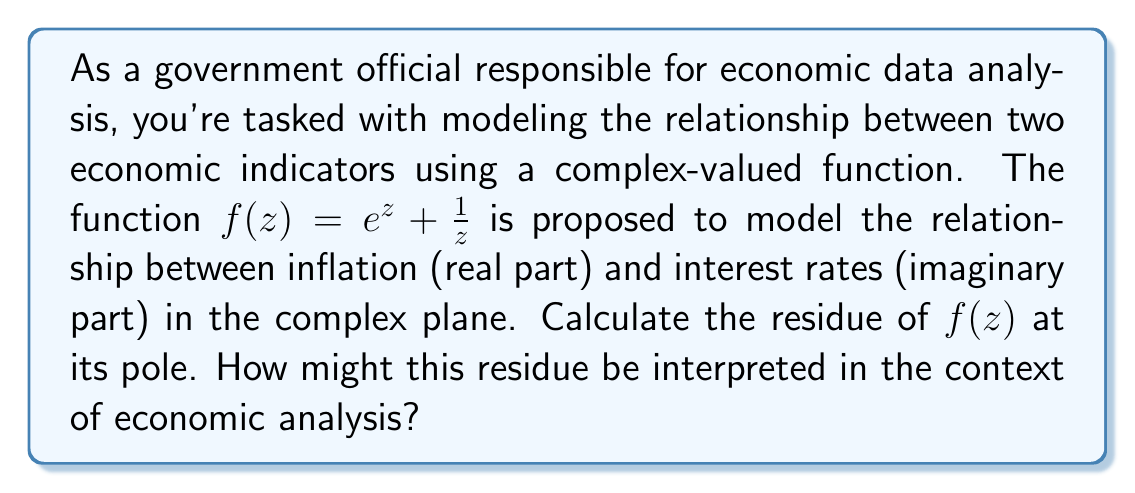Give your solution to this math problem. Let's approach this step-by-step:

1) First, we need to identify the pole of the function $f(z) = e^z + \frac{1}{z}$.
   The pole occurs at $z = 0$, as this is where the fraction $\frac{1}{z}$ is undefined.

2) To find the residue, we need to determine the order of the pole.
   The term $e^z$ is entire (analytic everywhere), so it doesn't contribute to the pole.
   The term $\frac{1}{z}$ has a simple pole (order 1) at $z = 0$.

3) For a simple pole, we can use the formula:
   $$\text{Res}(f, 0) = \lim_{z \to 0} z f(z)$$

4) Applying this formula:
   $$\begin{align}
   \text{Res}(f, 0) &= \lim_{z \to 0} z(e^z + \frac{1}{z}) \\
   &= \lim_{z \to 0} (ze^z + 1) \\
   &= 0 + 1 = 1
   \end{align}$$

5) Therefore, the residue of $f(z)$ at $z = 0$ is 1.

Interpretation in economic context:
The residue represents the "strength" of the singularity in the complex plane. In this economic model, a residue of 1 suggests a balanced, non-zero interaction between inflation and interest rates at the critical point (0,0). This could indicate that small changes in either variable near this point have a proportional and stable effect on the other, which might be interpreted as a sign of economic stability or equilibrium in the relationship between these two indicators.
Answer: 1 